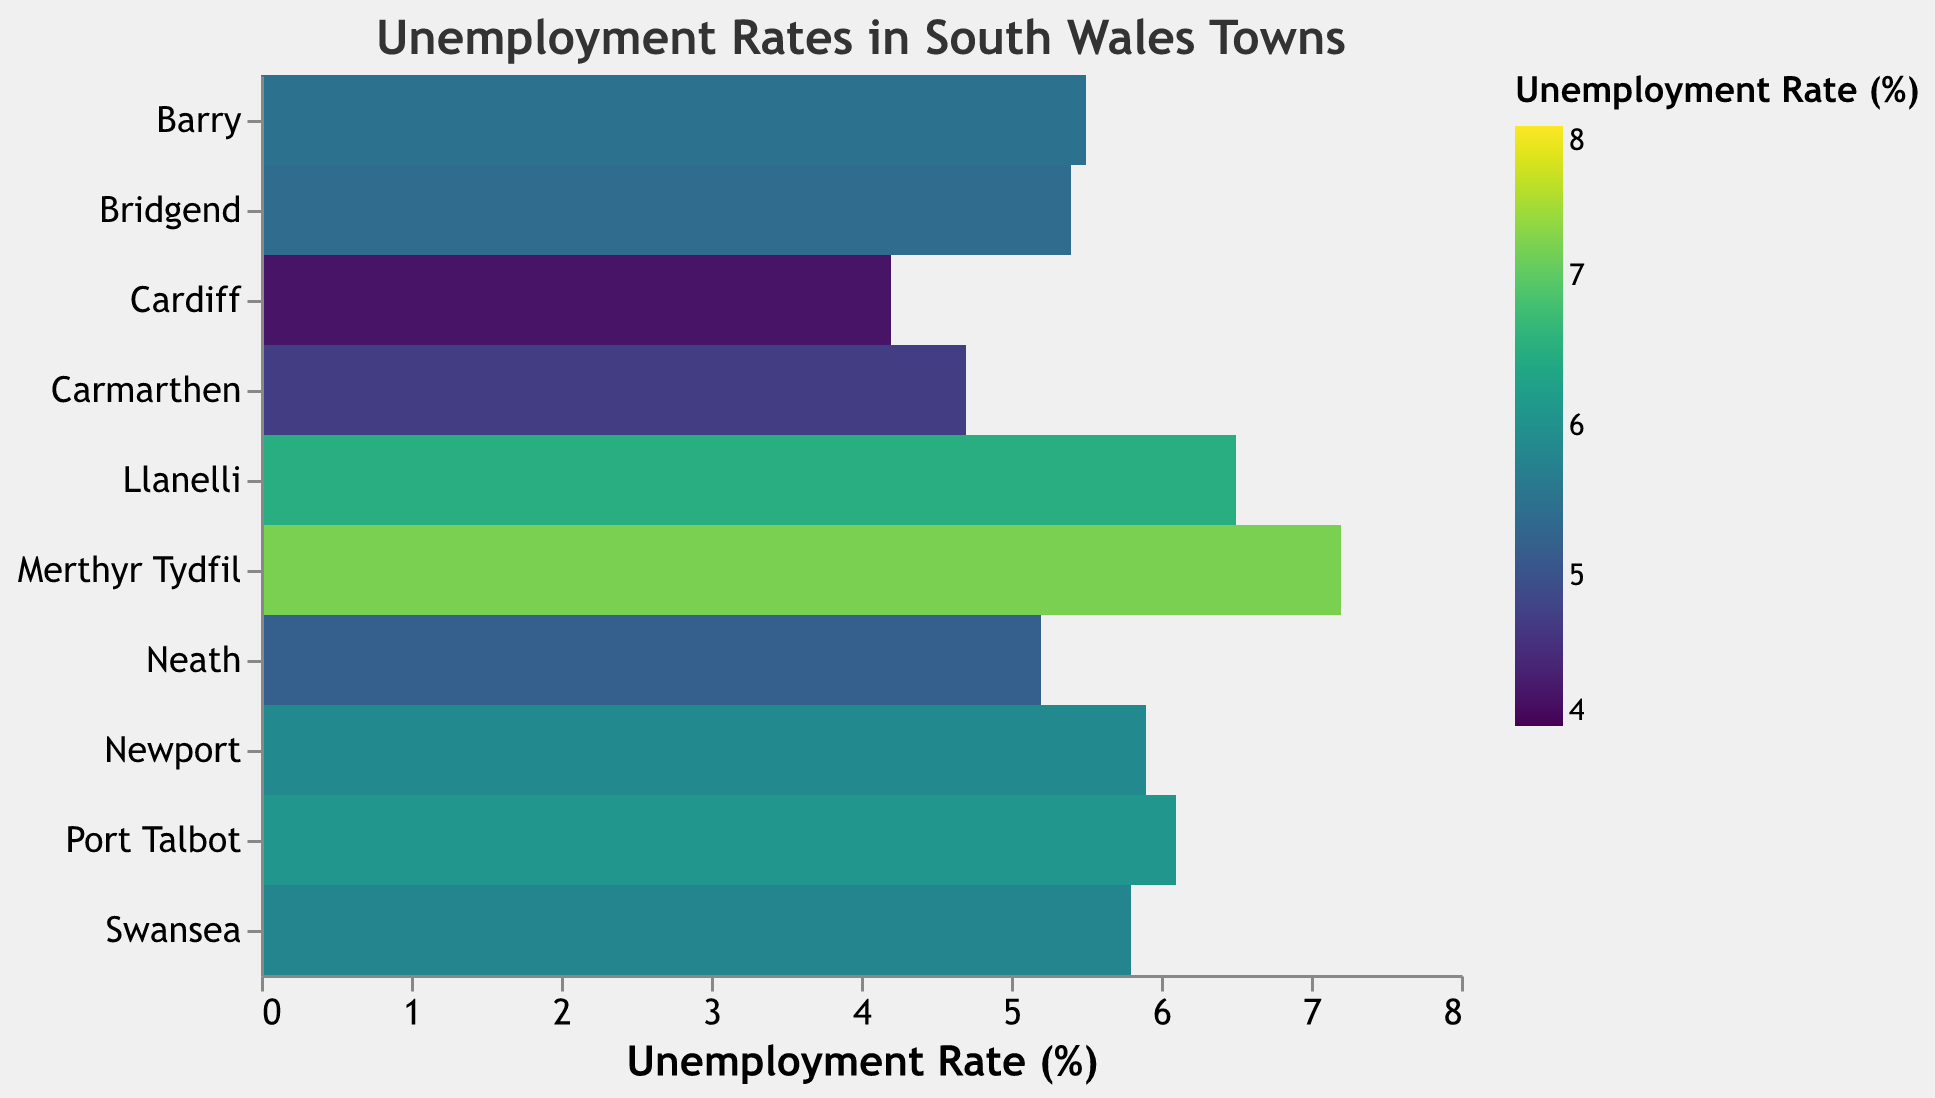What is the title of the heatmap? The title of the heatmap is written at the top, and it reads "Unemployment Rates in South Wales Towns".
Answer: Unemployment Rates in South Wales Towns Which town in South Wales has the highest unemployment rate according to the heatmap? The heatmap uses color intensity to represent unemployment rates and shows Merthyr Tydfil with the darkest color, indicating the highest unemployment rate of 7.2%.
Answer: Merthyr Tydfil How does Llanelli's unemployment rate compare to Cardiff's? Llanelli has an unemployment rate of 6.5%, while Cardiff has a much lower rate of 4.2%, making Llanelli's rate 2.3% higher than Cardiff's.
Answer: 2.3% higher What is the range of unemployment rates represented on the heatmap? The heatmap legend indicates that the scale runs from 4% to 8%, which is supported by the data, where the lowest rate is 4.2% and the highest is 7.2%.
Answer: 4% to 8% How many towns have an unemployment rate greater than 6%? According to the heatmap data, Llanelli (6.5%), Port Talbot (6.1%), and Merthyr Tydfil (7.2%) all have unemployment rates greater than 6%. This totals three towns.
Answer: 3 Which town has a close unemployment rate to Barry? Barry has an unemployment rate of 5.5%, and looking at the heatmap, Bridgend has an unemployment rate very close to this, at 5.4%.
Answer: Bridgend Is Newport’s unemployment rate higher than Swansea's? The heatmap shows that Newport has an unemployment rate of 5.9%, whereas Swansea's rate is 5.8%, making Newport's rate slightly higher.
Answer: Yes What is the average unemployment rate of the towns shown on the heatmap? Sum the unemployment rates of all towns: 6.5 (Llanelli) + 5.8 (Swansea) + 4.7 (Carmarthen) + 5.2 (Neath) + 6.1 (Port Talbot) + 5.4 (Bridgend) + 7.2 (Merthyr Tydfil) + 5.9 (Newport) + 4.2 (Cardiff) + 5.5 (Barry) = 56.5. Divide by the number of towns (10): 56.5 / 10 = 5.65%.
Answer: 5.65% Which towns have an unemployment rate below the average rate of the selection? The calculated average unemployment rate is 5.65%. The towns with rates above this mean are Llanelli, Port Talbot, Merthyr Tydfil, and Newport. The remaining towns (Swansea, Carmarthen, Neath, Bridgend, Cardiff, Barry) are below the average.
Answer: Swansea, Carmarthen, Neath, Bridgend, Cardiff, Barry What is the median unemployment rate of the towns? To find the median, first, sort the rates: 4.2 (Cardiff), 4.7 (Carmarthen), 5.2 (Neath), 5.4 (Bridgend), 5.5 (Barry), 5.8 (Swansea), 5.9 (Newport), 6.1 (Port Talbot), 6.5 (Llanelli), 7.2 (Merthyr Tydfil). As there are 10 values, the median will be the average of the 5th and 6th: (5.5 + 5.8) / 2 = 5.65%.
Answer: 5.65% 